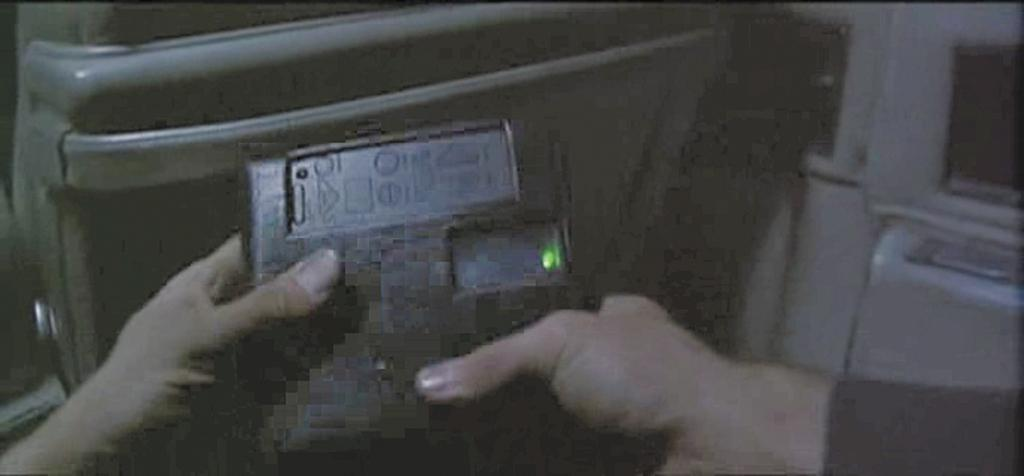What is the setting of the image? The image is taken inside a vehicle. What can be seen in the foreground of the image? Two hands are visible in the foreground. What are the hands holding? The hands are holding an electronic instrument. How many servants are visible in the image? There are no servants visible in the image. What type of power source is used by the electronic instrument in the image? The image does not provide information about the power source of the electronic instrument. 